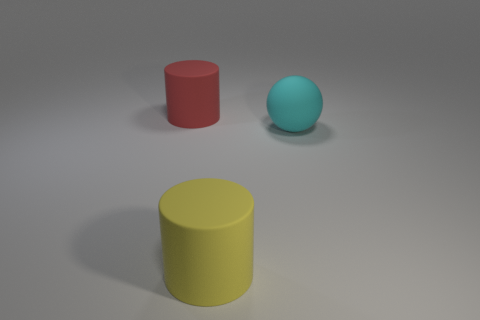Add 3 yellow rubber things. How many objects exist? 6 Subtract all cylinders. How many objects are left? 1 Subtract 1 spheres. How many spheres are left? 0 Subtract all blue balls. Subtract all purple cubes. How many balls are left? 1 Subtract all yellow cubes. How many red cylinders are left? 1 Subtract all large red cylinders. Subtract all big blue rubber cylinders. How many objects are left? 2 Add 2 large spheres. How many large spheres are left? 3 Add 2 red matte objects. How many red matte objects exist? 3 Subtract all red cylinders. How many cylinders are left? 1 Subtract 0 purple balls. How many objects are left? 3 